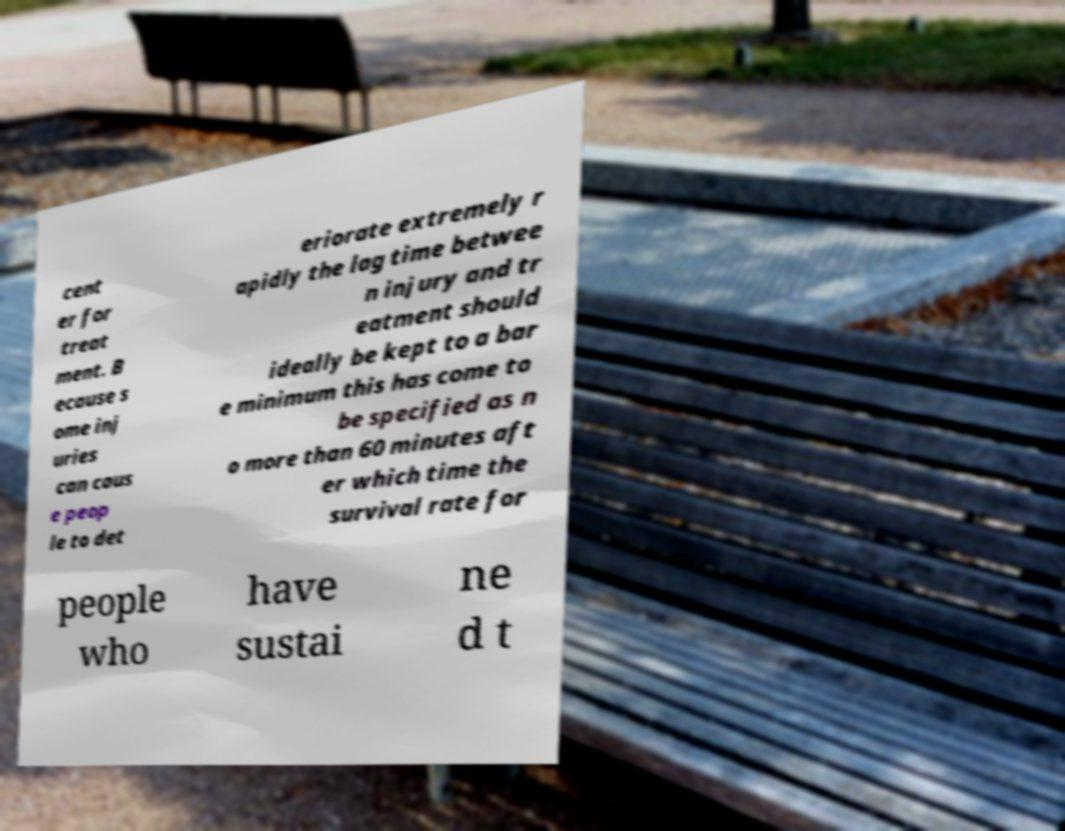For documentation purposes, I need the text within this image transcribed. Could you provide that? cent er for treat ment. B ecause s ome inj uries can caus e peop le to det eriorate extremely r apidly the lag time betwee n injury and tr eatment should ideally be kept to a bar e minimum this has come to be specified as n o more than 60 minutes aft er which time the survival rate for people who have sustai ne d t 